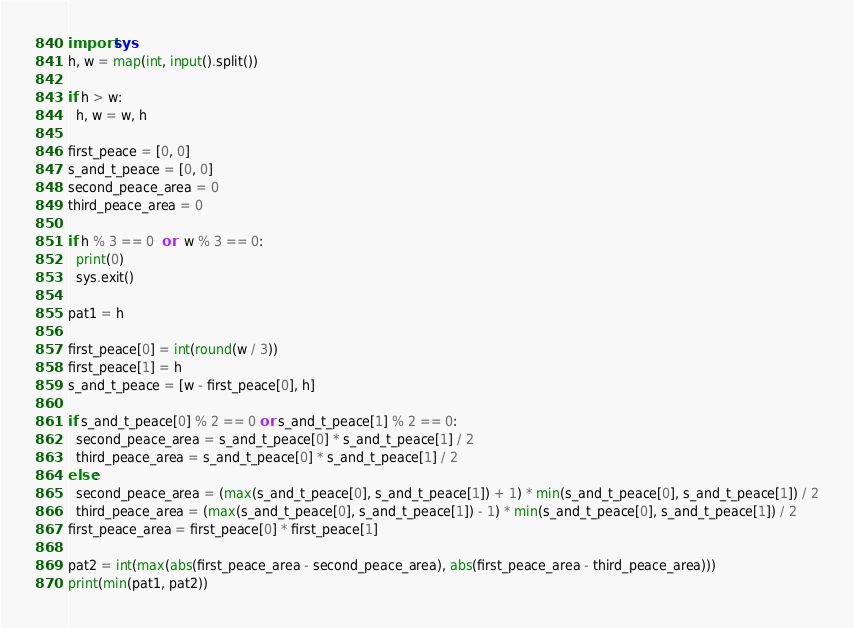Convert code to text. <code><loc_0><loc_0><loc_500><loc_500><_Python_>import sys
h, w = map(int, input().split())

if h > w:
  h, w = w, h

first_peace = [0, 0]
s_and_t_peace = [0, 0]
second_peace_area = 0
third_peace_area = 0

if h % 3 == 0  or  w % 3 == 0:
  print(0)
  sys.exit()

pat1 = h
  
first_peace[0] = int(round(w / 3))
first_peace[1] = h
s_and_t_peace = [w - first_peace[0], h]

if s_and_t_peace[0] % 2 == 0 or s_and_t_peace[1] % 2 == 0:
  second_peace_area = s_and_t_peace[0] * s_and_t_peace[1] / 2
  third_peace_area = s_and_t_peace[0] * s_and_t_peace[1] / 2
else:
  second_peace_area = (max(s_and_t_peace[0], s_and_t_peace[1]) + 1) * min(s_and_t_peace[0], s_and_t_peace[1]) / 2
  third_peace_area = (max(s_and_t_peace[0], s_and_t_peace[1]) - 1) * min(s_and_t_peace[0], s_and_t_peace[1]) / 2
first_peace_area = first_peace[0] * first_peace[1]

pat2 = int(max(abs(first_peace_area - second_peace_area), abs(first_peace_area - third_peace_area)))
print(min(pat1, pat2))</code> 